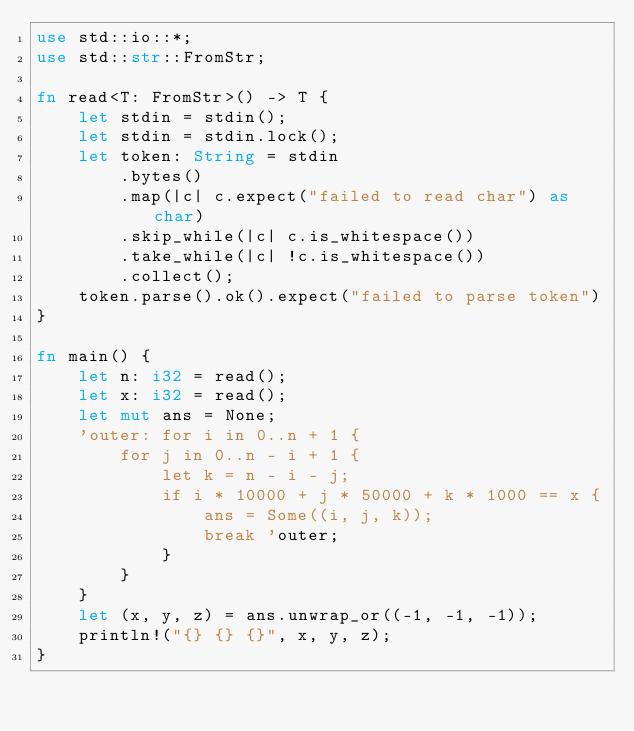<code> <loc_0><loc_0><loc_500><loc_500><_Rust_>use std::io::*;
use std::str::FromStr;

fn read<T: FromStr>() -> T {
    let stdin = stdin();
    let stdin = stdin.lock();
    let token: String = stdin
        .bytes()
        .map(|c| c.expect("failed to read char") as char)
        .skip_while(|c| c.is_whitespace())
        .take_while(|c| !c.is_whitespace())
        .collect();
    token.parse().ok().expect("failed to parse token")
}

fn main() {
    let n: i32 = read();
    let x: i32 = read();
    let mut ans = None;
    'outer: for i in 0..n + 1 {
        for j in 0..n - i + 1 {
            let k = n - i - j;
            if i * 10000 + j * 50000 + k * 1000 == x {
                ans = Some((i, j, k));
                break 'outer;
            }
        }
    }
    let (x, y, z) = ans.unwrap_or((-1, -1, -1));
    println!("{} {} {}", x, y, z);
}
</code> 